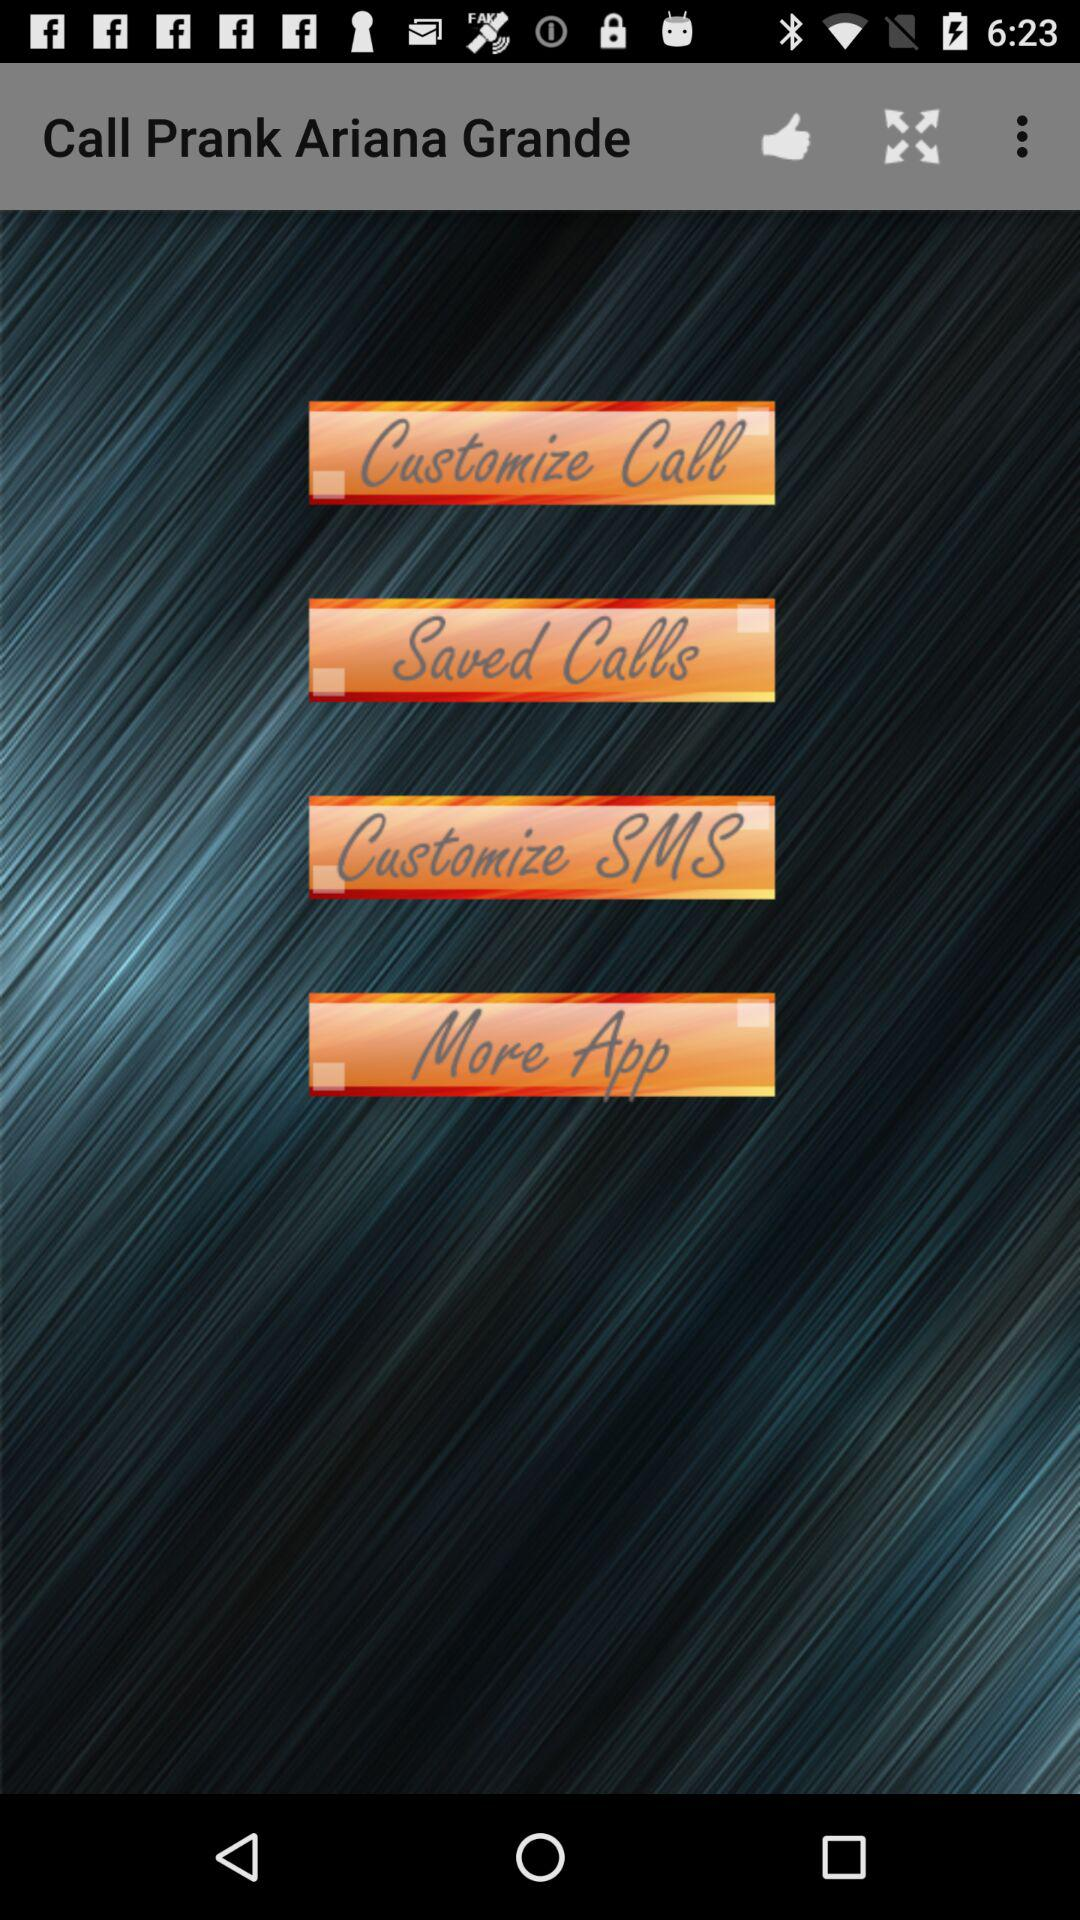What is the app name? The app name is "Call Prank Ariana Grande". 